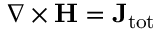Convert formula to latex. <formula><loc_0><loc_0><loc_500><loc_500>\nabla \times H = J _ { t o t }</formula> 